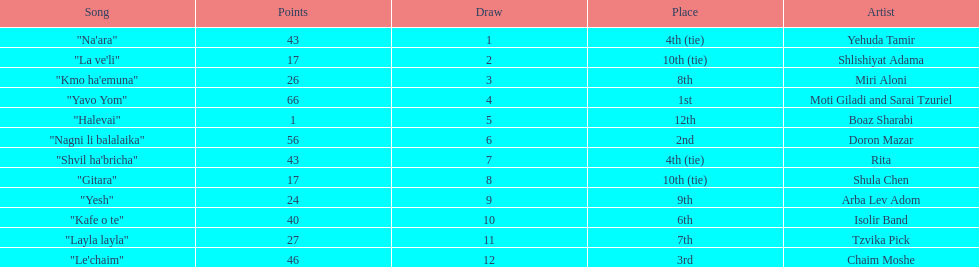What are the number of times an artist earned first place? 1. 